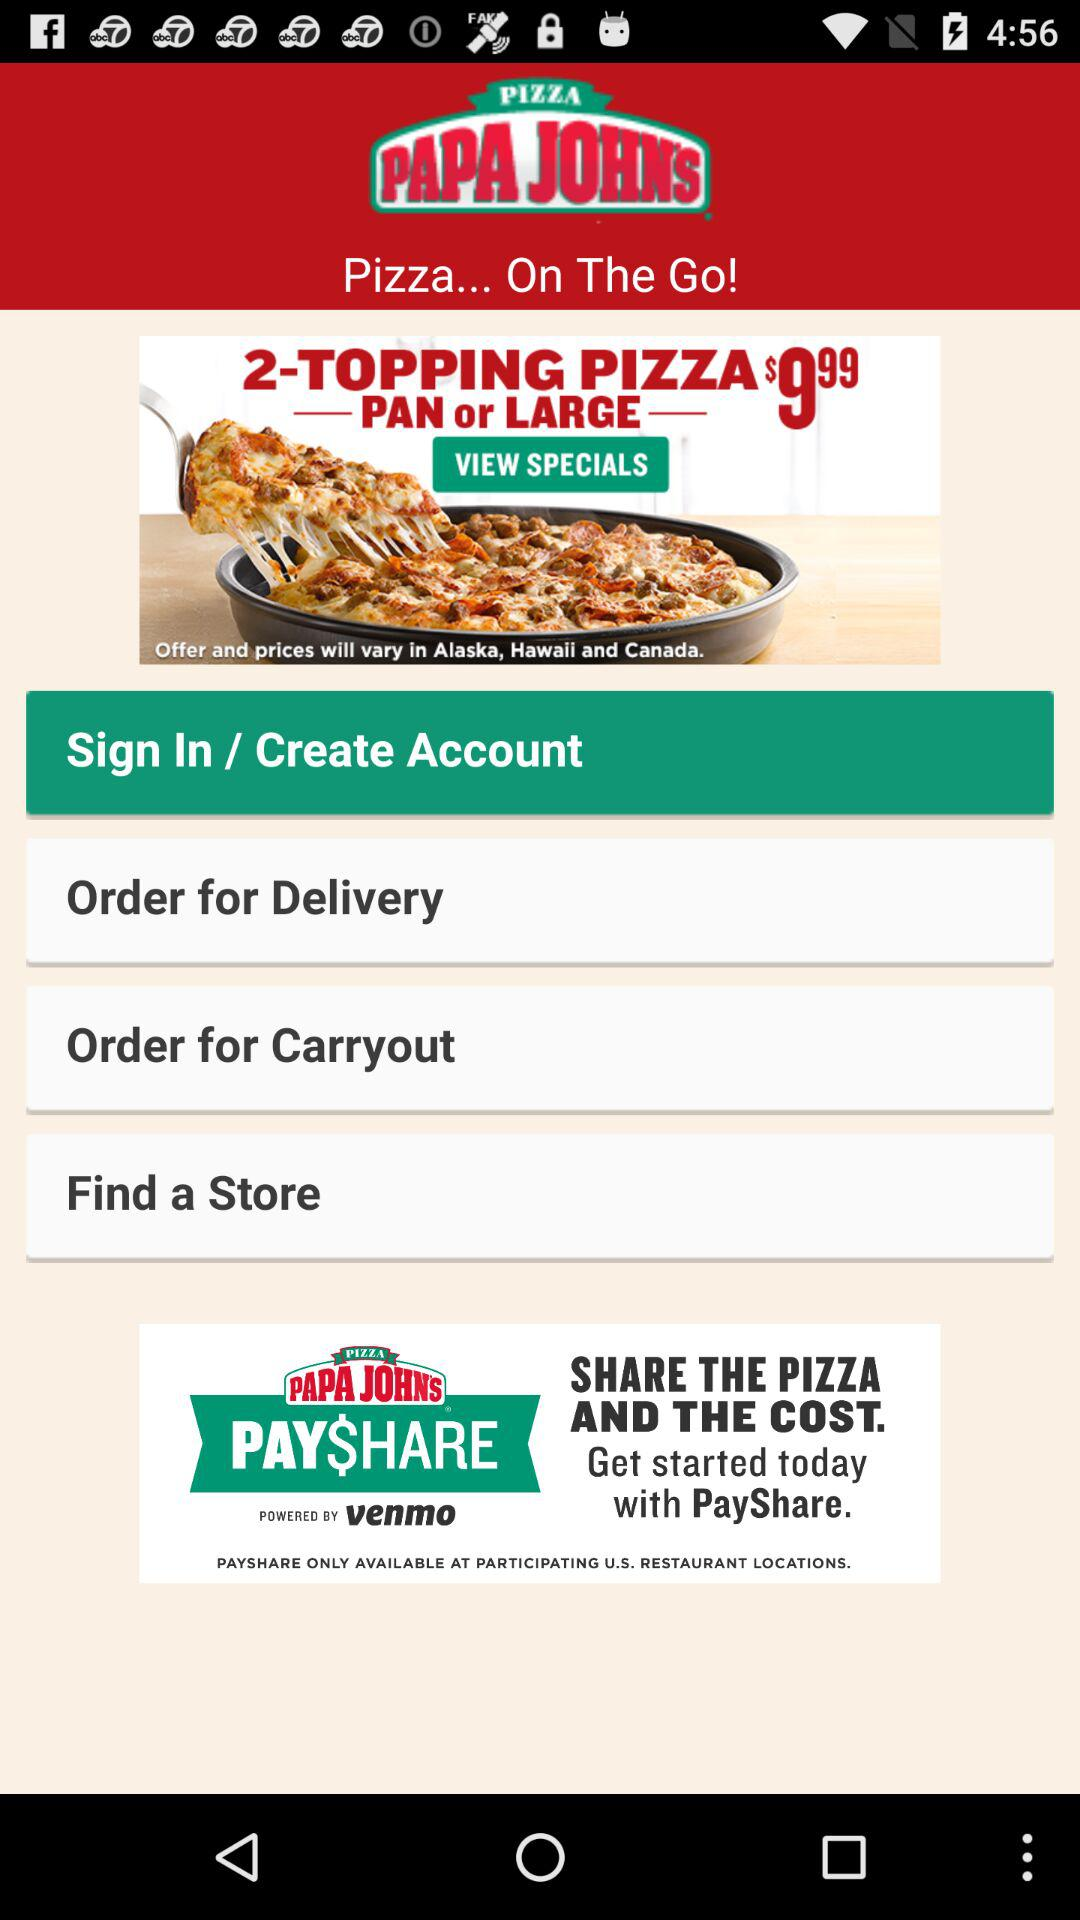What is the name of the application? The name of the application is "PIZZA PAPA JOHN'S". 